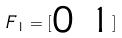<formula> <loc_0><loc_0><loc_500><loc_500>F _ { 1 } = [ \begin{matrix} 0 & 1 \end{matrix} ]</formula> 